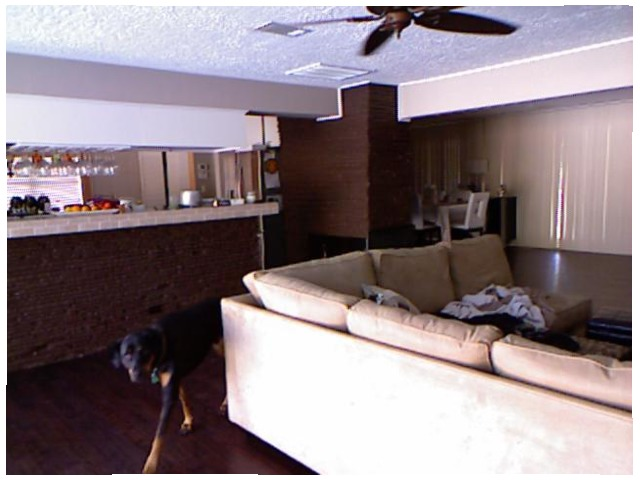<image>
Is there a fan on the ceiling? Yes. Looking at the image, I can see the fan is positioned on top of the ceiling, with the ceiling providing support. Where is the table in relation to the chair? Is it behind the chair? Yes. From this viewpoint, the table is positioned behind the chair, with the chair partially or fully occluding the table. 